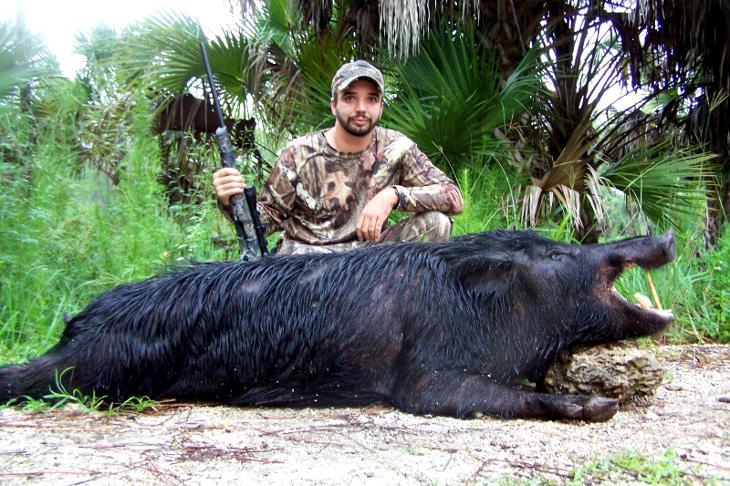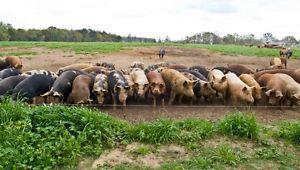The first image is the image on the left, the second image is the image on the right. Evaluate the accuracy of this statement regarding the images: "One image shows at least one hunter posing behind a warthog.". Is it true? Answer yes or no. Yes. The first image is the image on the left, the second image is the image on the right. Considering the images on both sides, is "An image shows at least one man in a camo hat crouched behind a dead hog lying on the ground with its mouth propped open." valid? Answer yes or no. Yes. 